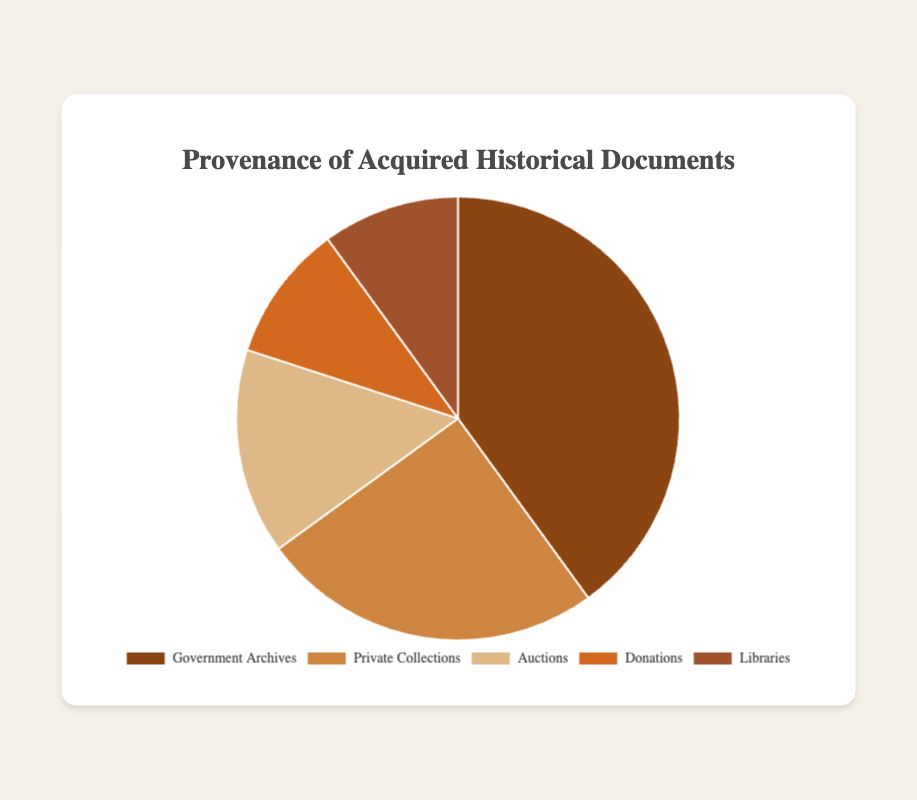Which source contributes the largest percentage of acquired historical documents? The largest slice of the pie chart corresponds to Government Archives, which has the highest percentage value.
Answer: Government Archives How much greater is the percentage of documents from Government Archives compared to Donations? Government Archives contributes 40% and Donations contribute 10%. The difference is calculated as 40% - 10% = 30%.
Answer: 30% Which two sources together contribute more than half of the documents? Government Archives and Private Collections contribute 40% and 25% respectively. Their combined total is 40% + 25% = 65%, which is more than half.
Answer: Government Archives and Private Collections What is the combined percentage for the least contributing sources? Donations and Libraries both contribute 10% each. Their combined total is 10% + 10% = 20%.
Answer: 20% What is the average percentage of the documents from all sources? To calculate the average, sum all percentages and then divide by the number of sources: (40% + 25% + 15% + 10% + 10%) / 5 = 100% / 5 = 20%.
Answer: 20% Which sources have an equal percentage of documents? From the pie chart, both Donations and Libraries contribute an equal percentage of 10%.
Answer: Donations and Libraries How does the percentage from Private Collections compare to the percentage from Auctions? Private Collections contribute 25% while Auctions contribute 15%. Private Collections contribute 10% more than Auctions.
Answer: Private Collections contribute 10% more What is the range of percentages across all sources? The highest percentage is 40% (Government Archives) and the lowest is 10% (Donations and Libraries). The range is calculated as 40% - 10% = 30%.
Answer: 30% What is the total percentage represented by the sources that each contribute more than 20%? Government Archives (40%) and Private Collections (25%) each contribute more than 20%. Their total is 40% + 25% = 65%.
Answer: 65% 